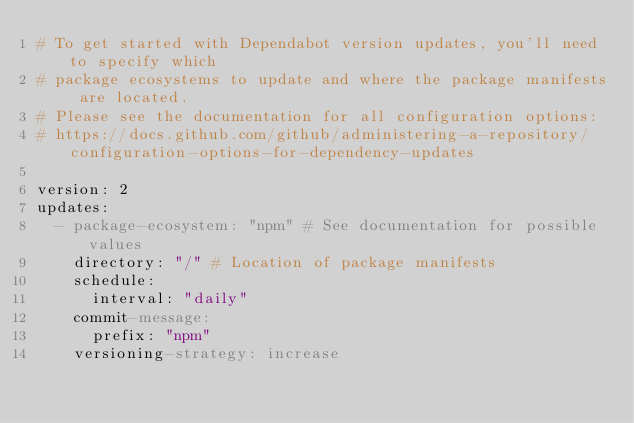Convert code to text. <code><loc_0><loc_0><loc_500><loc_500><_YAML_># To get started with Dependabot version updates, you'll need to specify which
# package ecosystems to update and where the package manifests are located.
# Please see the documentation for all configuration options:
# https://docs.github.com/github/administering-a-repository/configuration-options-for-dependency-updates

version: 2
updates:
  - package-ecosystem: "npm" # See documentation for possible values
    directory: "/" # Location of package manifests
    schedule:
      interval: "daily"
    commit-message:
      prefix: "npm"
    versioning-strategy: increase
</code> 